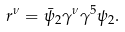Convert formula to latex. <formula><loc_0><loc_0><loc_500><loc_500>r ^ { \nu } = \bar { \psi } _ { 2 } \gamma ^ { \nu } \gamma ^ { 5 } \psi _ { 2 } .</formula> 